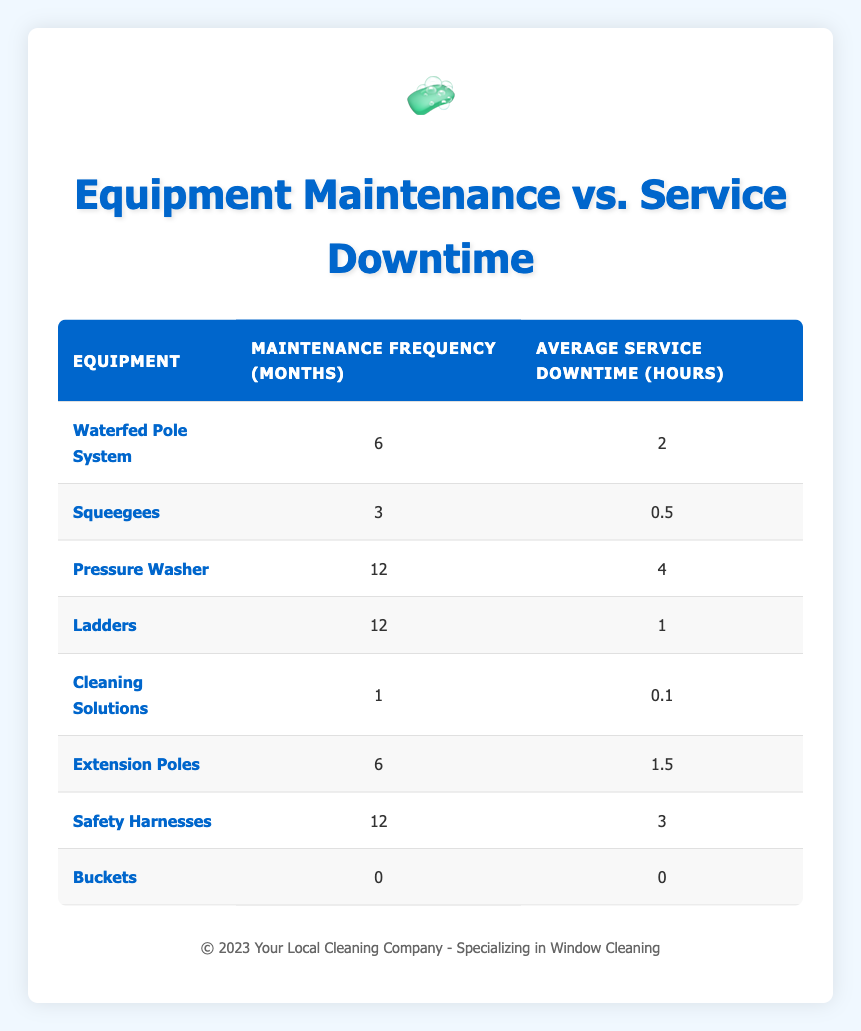What is the maintenance frequency for the Cleaning Solutions? From the table, we can directly look under the "Maintenance Frequency (months)" column for the "Cleaning Solutions" row. It shows 1 month.
Answer: 1 Which equipment has the highest average service downtime? By reviewing the "Average Service Downtime (hours)" column, we find that the "Pressure Washer" has the highest value of 4 hours.
Answer: Pressure Washer Is the average service downtime for Safety Harnesses greater than 2 hours? Checking the "Average Service Downtime (hours)" for "Safety Harnesses," it shows 3 hours. Since 3 is greater than 2, the answer is yes.
Answer: Yes What is the average maintenance frequency for equipment with an average service downtime of more than 2 hours? We identify the equipment with downtimes more than 2 hours, which are "Pressure Washer" (12 months) and "Safety Harnesses" (12 months). Calculating the average: (12 + 12) / 2 = 12.
Answer: 12 How many pieces of equipment require maintenance every 6 months? The table shows "Waterfed Pole System" and "Extension Poles" with a maintenance frequency of 6 months. Therefore, there are two pieces of equipment.
Answer: 2 Does the average service downtime increase with the maintenance frequency? To analyze this, we examine pairs of rows for both metrics. Comparing maintenance frequency to downtime shows that higher frequence does not consistently lead to higher downtimes (e.g., "Waterfed Pole System" is 6 and 2 hours, while "Pressure Washer" is 12 and 4).
Answer: No What is the total average service downtime for all equipment listed? We can sum the average service downtimes: (2 + 0.5 + 4 + 1 + 0.1 + 1.5 + 3 + 0) = 12.1 hours. We divide this by the total of 8 equipment pieces: 12.1 / 8 = 1.5125 hours, rounded to two decimal places, gives us approximately 1.51 hours.
Answer: 1.51 Which equipment has the shortest maintenance frequency? From the table, we can observe the "Buckets" entry, with a maintenance frequency listed as 0 months, indicating no maintenance required.
Answer: Buckets Is there any equipment that has an average service downtime of 0 hours? Looking under the "Average Service Downtime (hours)" column, we see the "Buckets" entry shows an downtime of 0 hours. Thus, the answer is yes.
Answer: Yes 